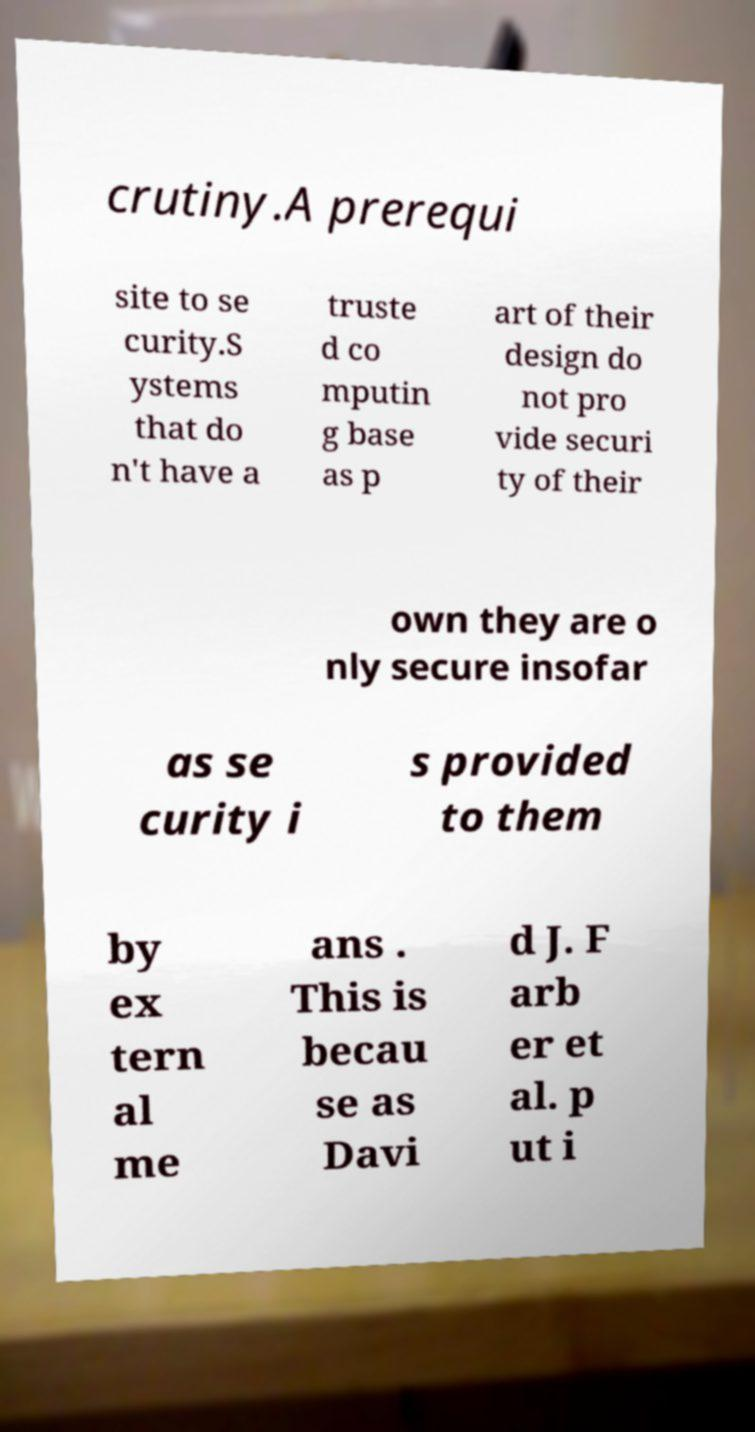Can you read and provide the text displayed in the image?This photo seems to have some interesting text. Can you extract and type it out for me? crutiny.A prerequi site to se curity.S ystems that do n't have a truste d co mputin g base as p art of their design do not pro vide securi ty of their own they are o nly secure insofar as se curity i s provided to them by ex tern al me ans . This is becau se as Davi d J. F arb er et al. p ut i 